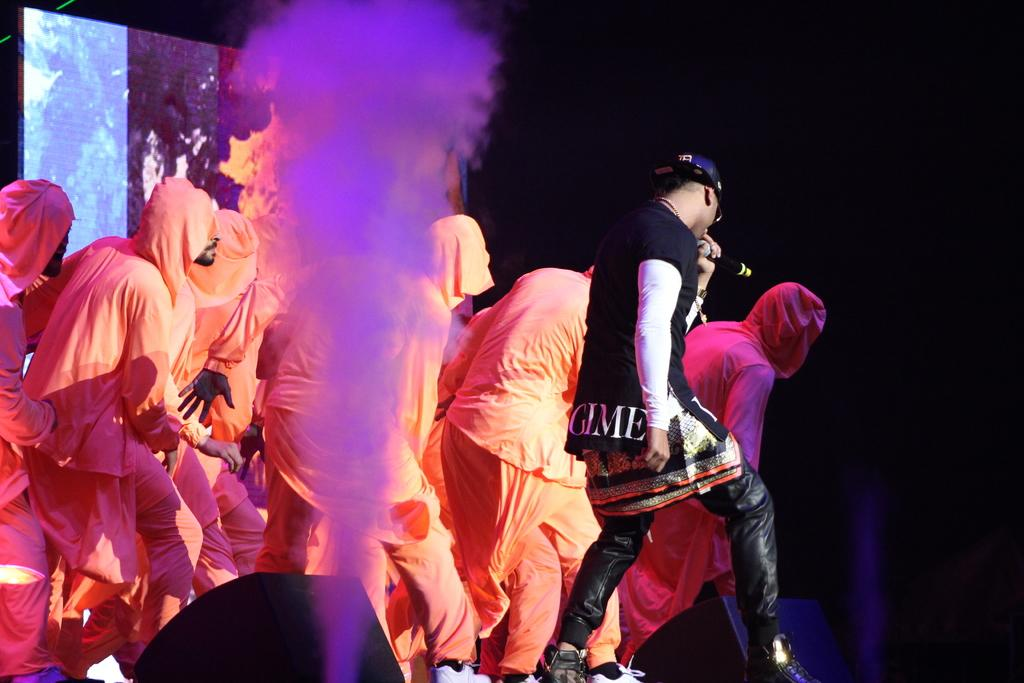What is the person in the image doing? The person is standing and singing a song in the image. How is the person amplifying their voice? The person is using a microphone to amplify their voice. Are there any other people visible in the image? Yes, there are people behind the person in the image. What can be seen in the background of the image? There is smoke visible in the image. What is used to project the sound in the image? There are speakers present in the image. What type of baseball play is being executed in the image? There is no baseball play present in the image; it features a person singing with a microphone. How does the person stretch their vocal cords while singing in the image? The image does not show the person stretching their vocal cords; it only shows them singing with a microphone. 